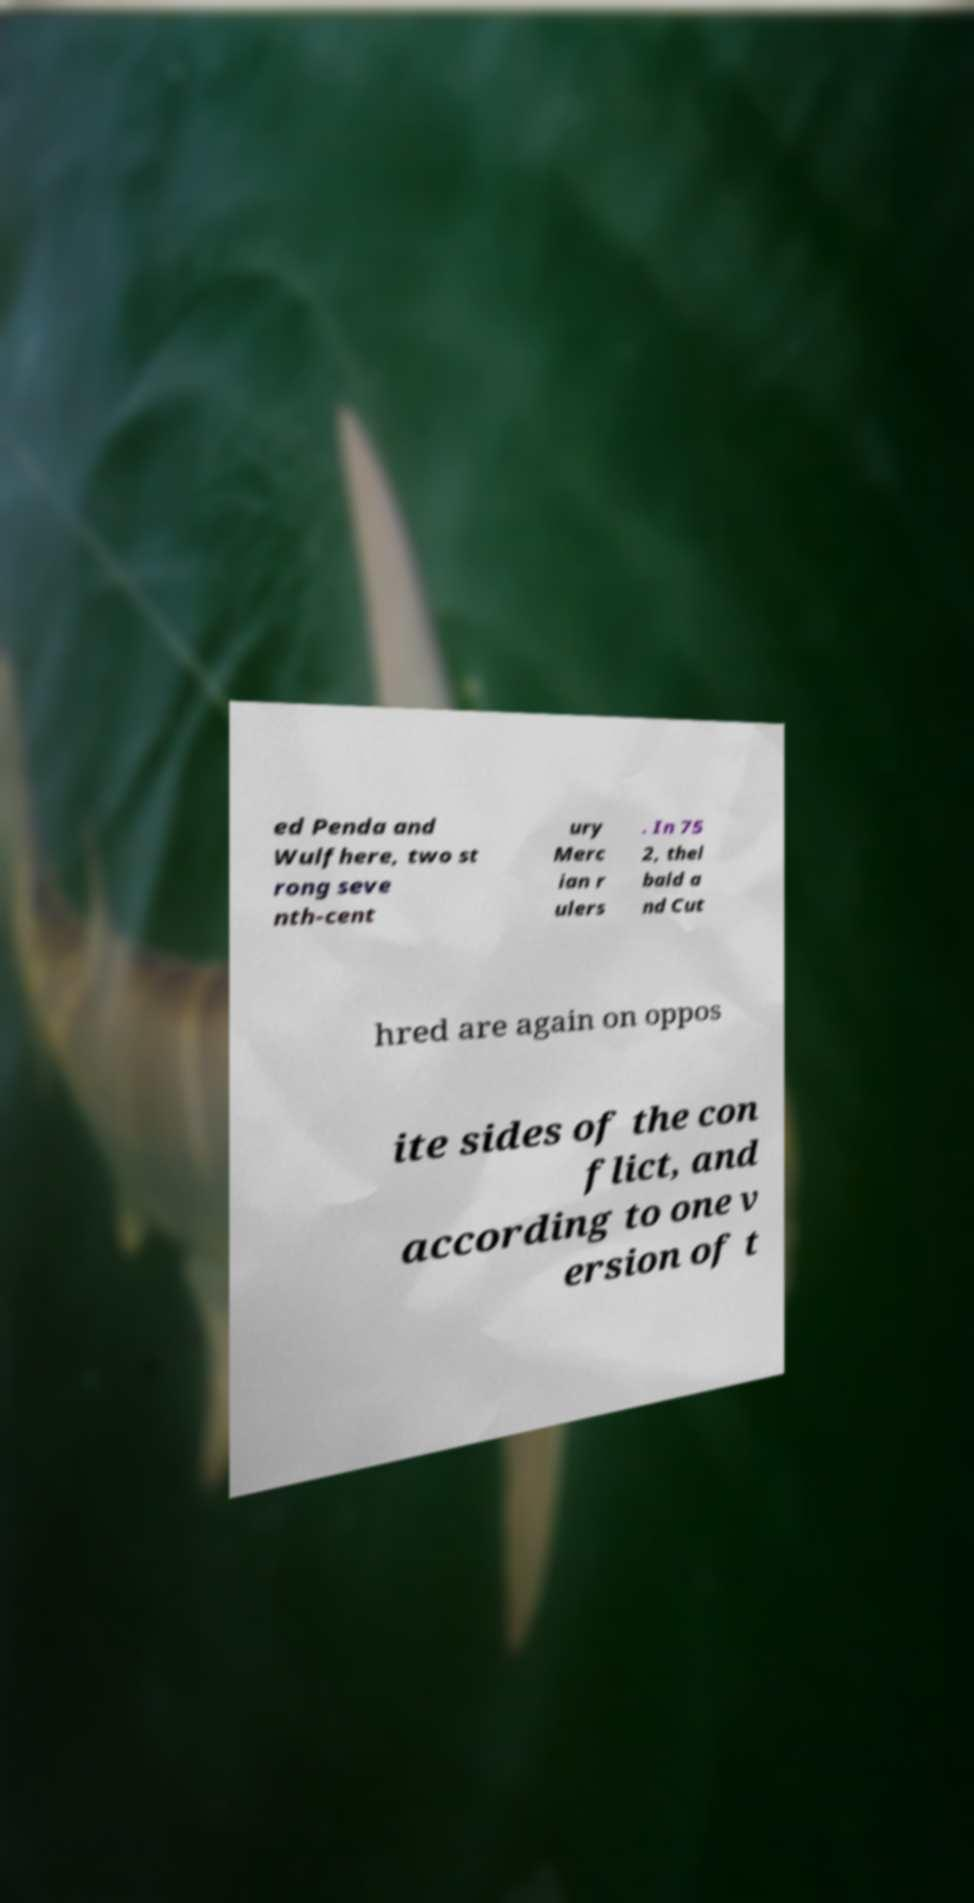Could you extract and type out the text from this image? ed Penda and Wulfhere, two st rong seve nth-cent ury Merc ian r ulers . In 75 2, thel bald a nd Cut hred are again on oppos ite sides of the con flict, and according to one v ersion of t 